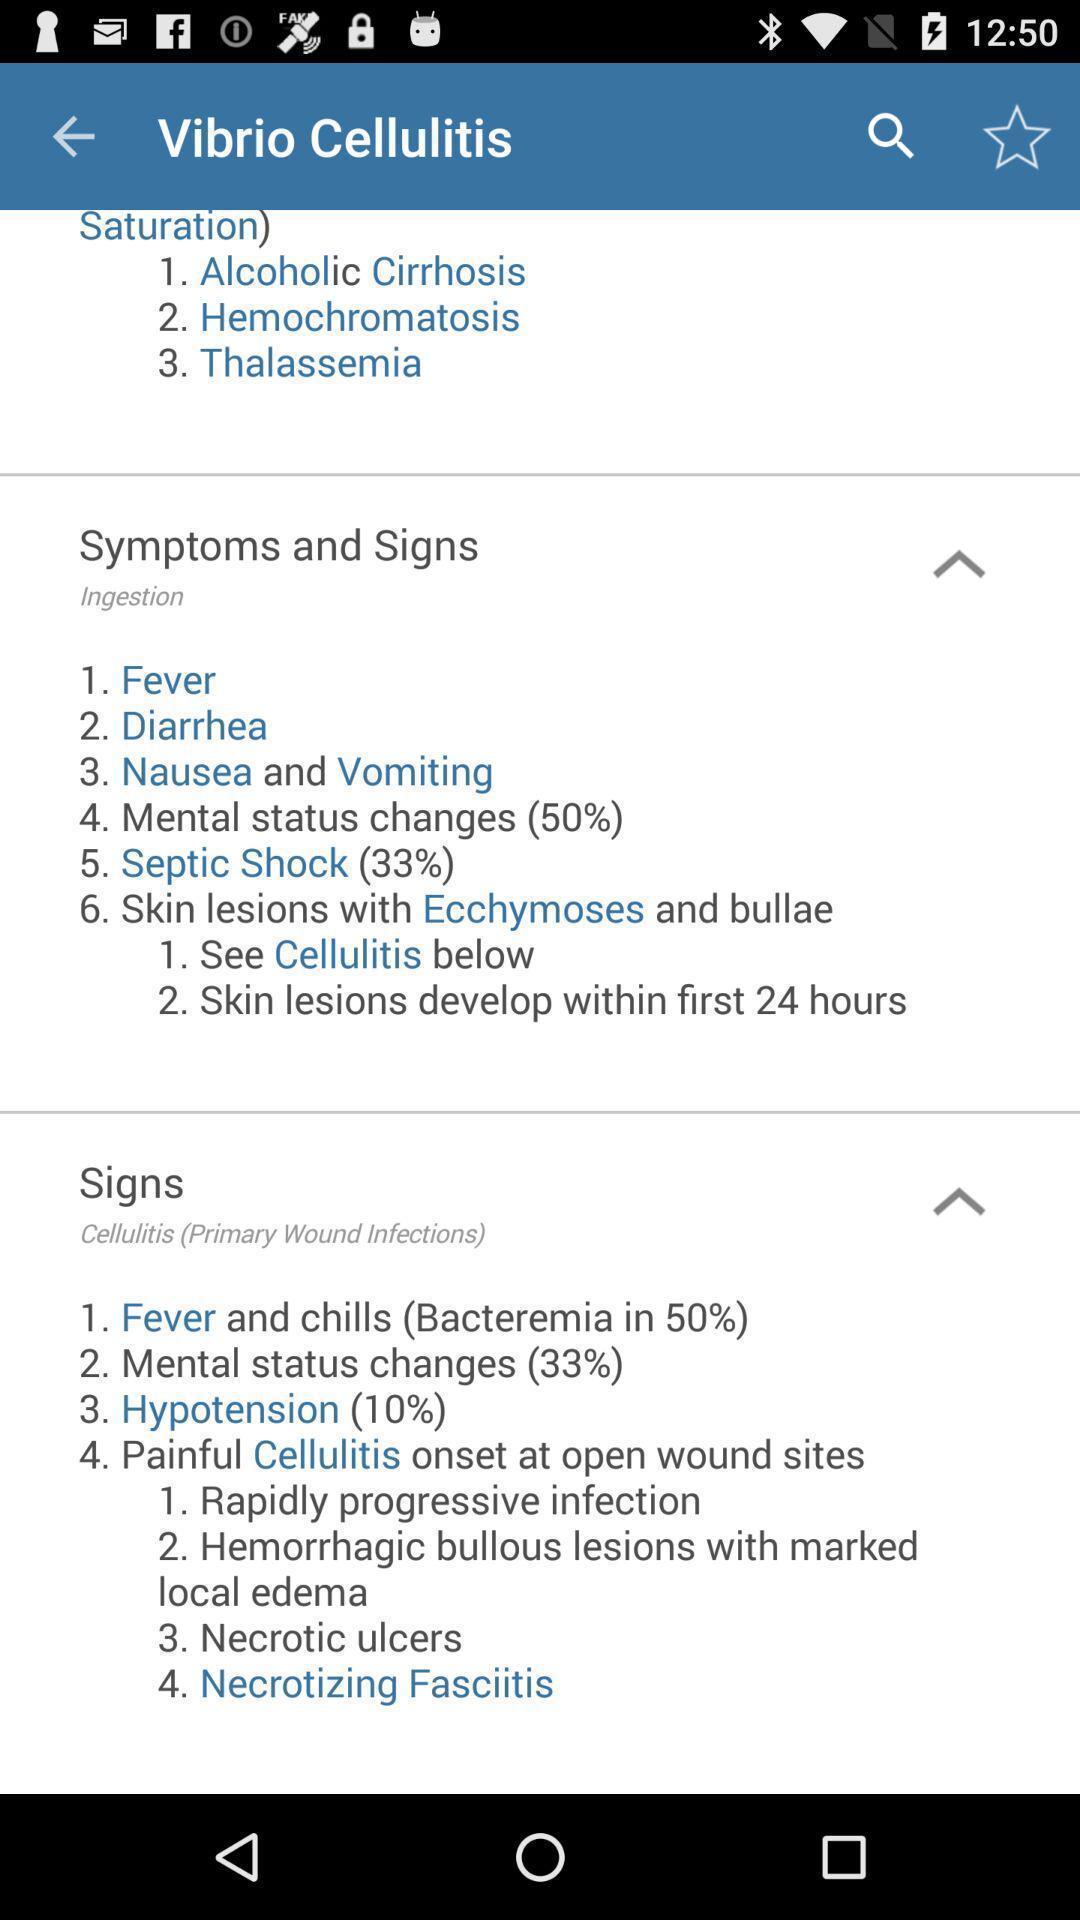Please provide a description for this image. Page showing the data of a medical app. 